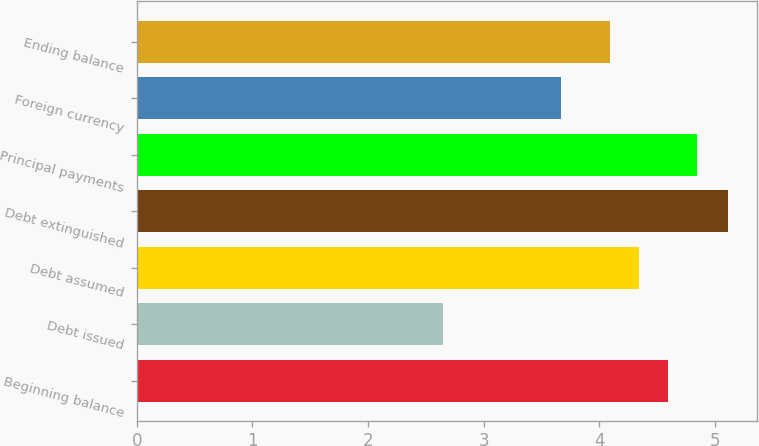<chart> <loc_0><loc_0><loc_500><loc_500><bar_chart><fcel>Beginning balance<fcel>Debt issued<fcel>Debt assumed<fcel>Debt extinguished<fcel>Principal payments<fcel>Foreign currency<fcel>Ending balance<nl><fcel>4.59<fcel>2.65<fcel>4.34<fcel>5.11<fcel>4.84<fcel>3.67<fcel>4.09<nl></chart> 